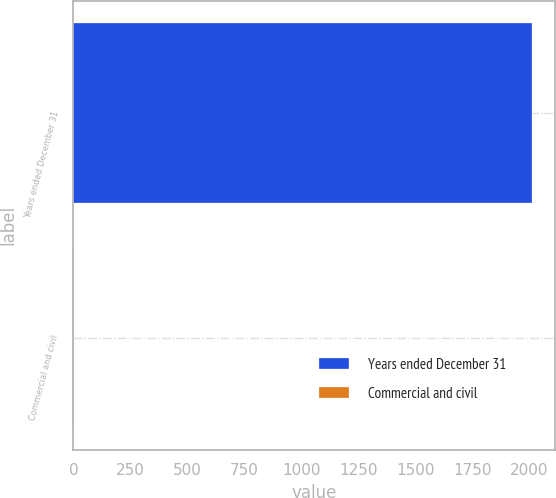Convert chart to OTSL. <chart><loc_0><loc_0><loc_500><loc_500><bar_chart><fcel>Years ended December 31<fcel>Commercial and civil<nl><fcel>2012<fcel>3<nl></chart> 